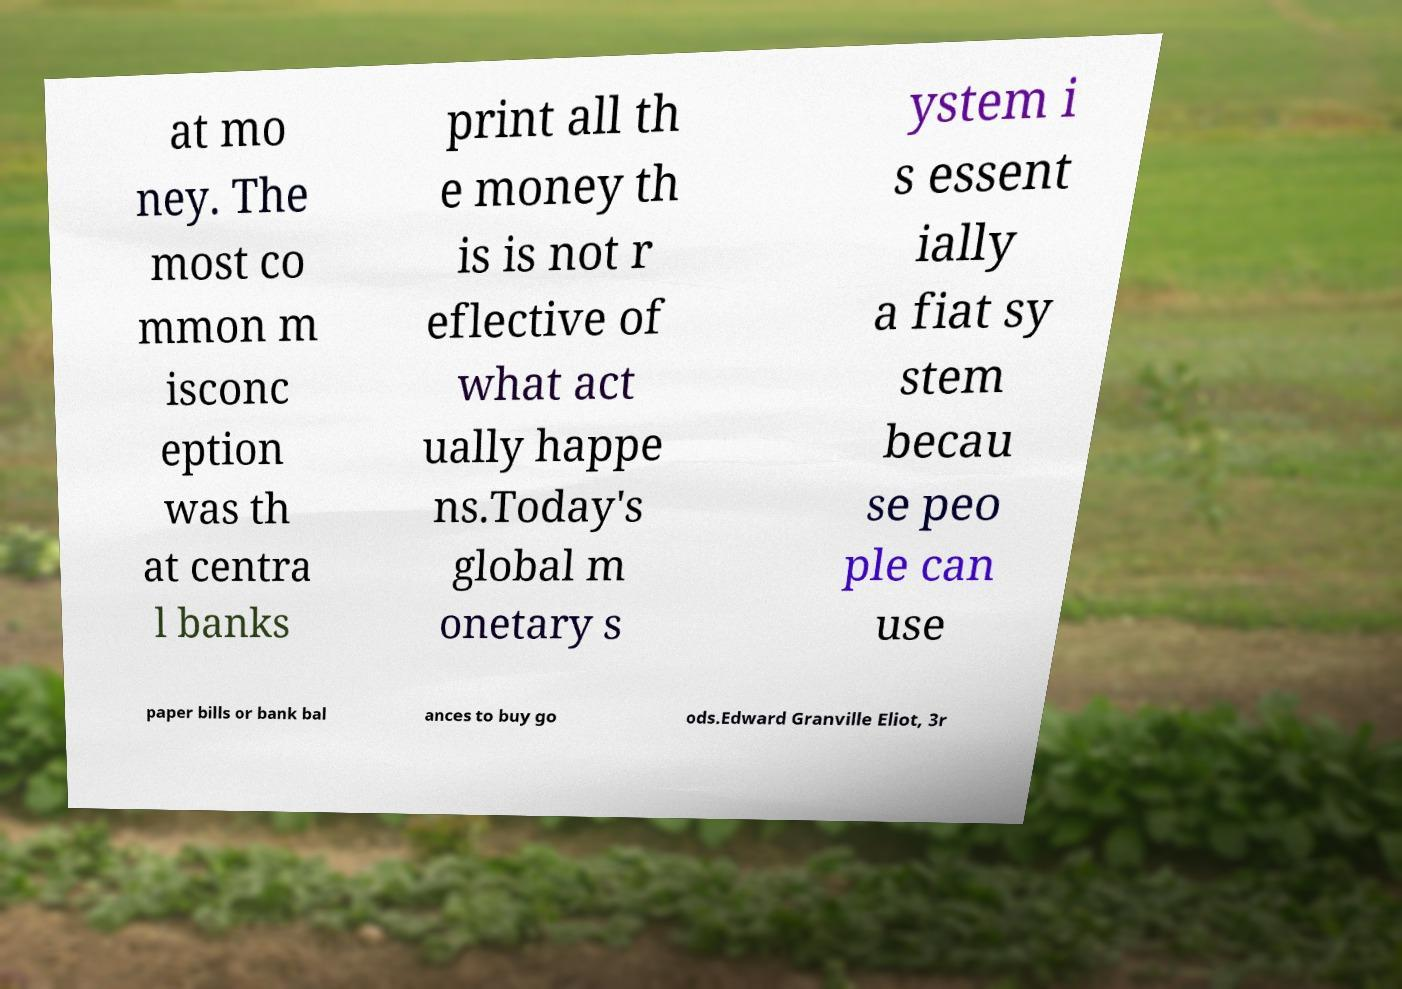Could you extract and type out the text from this image? at mo ney. The most co mmon m isconc eption was th at centra l banks print all th e money th is is not r eflective of what act ually happe ns.Today's global m onetary s ystem i s essent ially a fiat sy stem becau se peo ple can use paper bills or bank bal ances to buy go ods.Edward Granville Eliot, 3r 